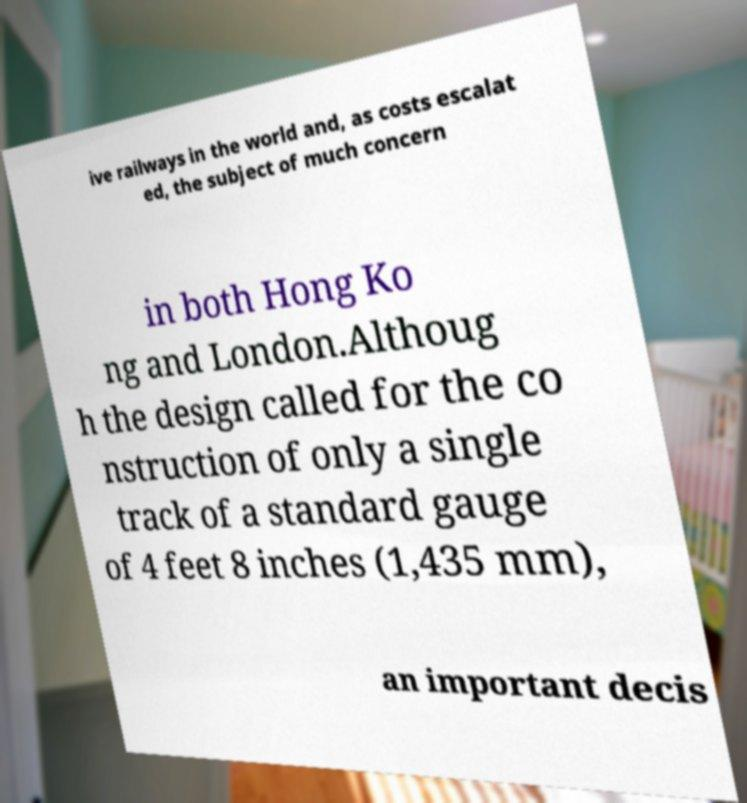Please identify and transcribe the text found in this image. ive railways in the world and, as costs escalat ed, the subject of much concern in both Hong Ko ng and London.Althoug h the design called for the co nstruction of only a single track of a standard gauge of 4 feet 8 inches (1,435 mm), an important decis 